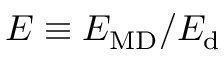Convert formula to latex. <formula><loc_0><loc_0><loc_500><loc_500>E \equiv E _ { M D } / E _ { d }</formula> 